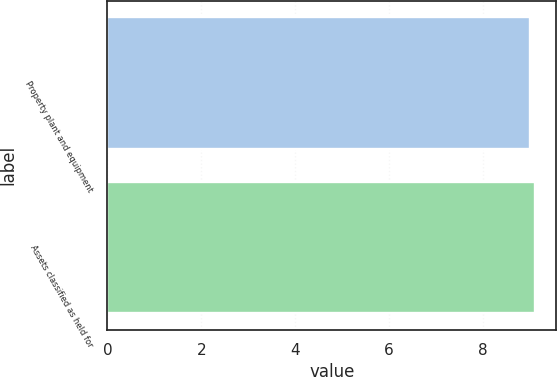Convert chart. <chart><loc_0><loc_0><loc_500><loc_500><bar_chart><fcel>Property plant and equipment<fcel>Assets classified as held for<nl><fcel>9<fcel>9.1<nl></chart> 